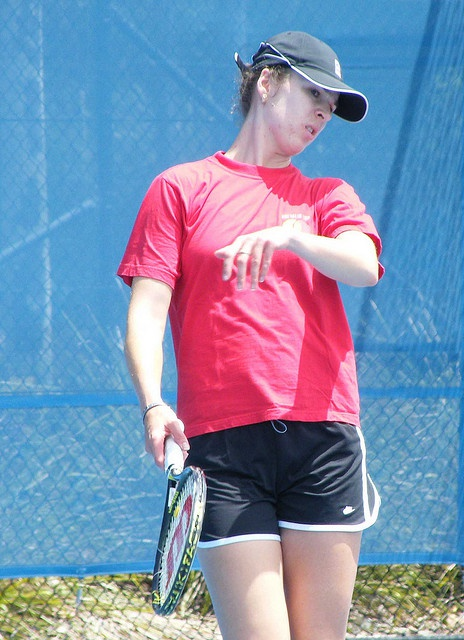Describe the objects in this image and their specific colors. I can see people in gray, white, brown, black, and lightpink tones and tennis racket in gray, white, lightblue, blue, and darkgray tones in this image. 